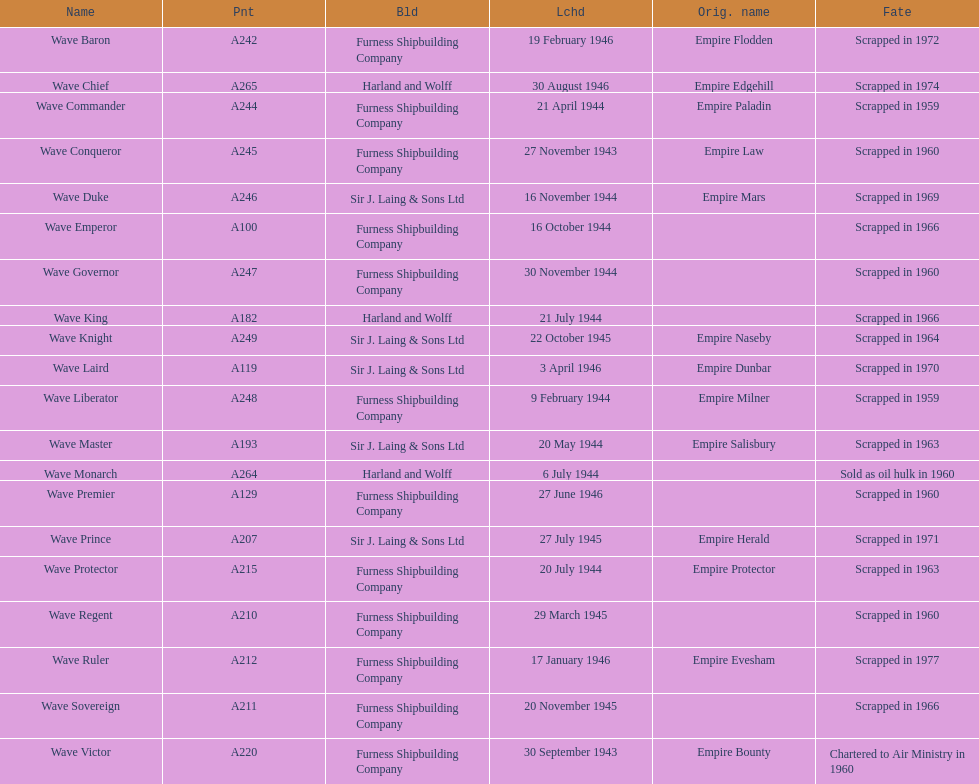What date was the first ship launched? 30 September 1943. 